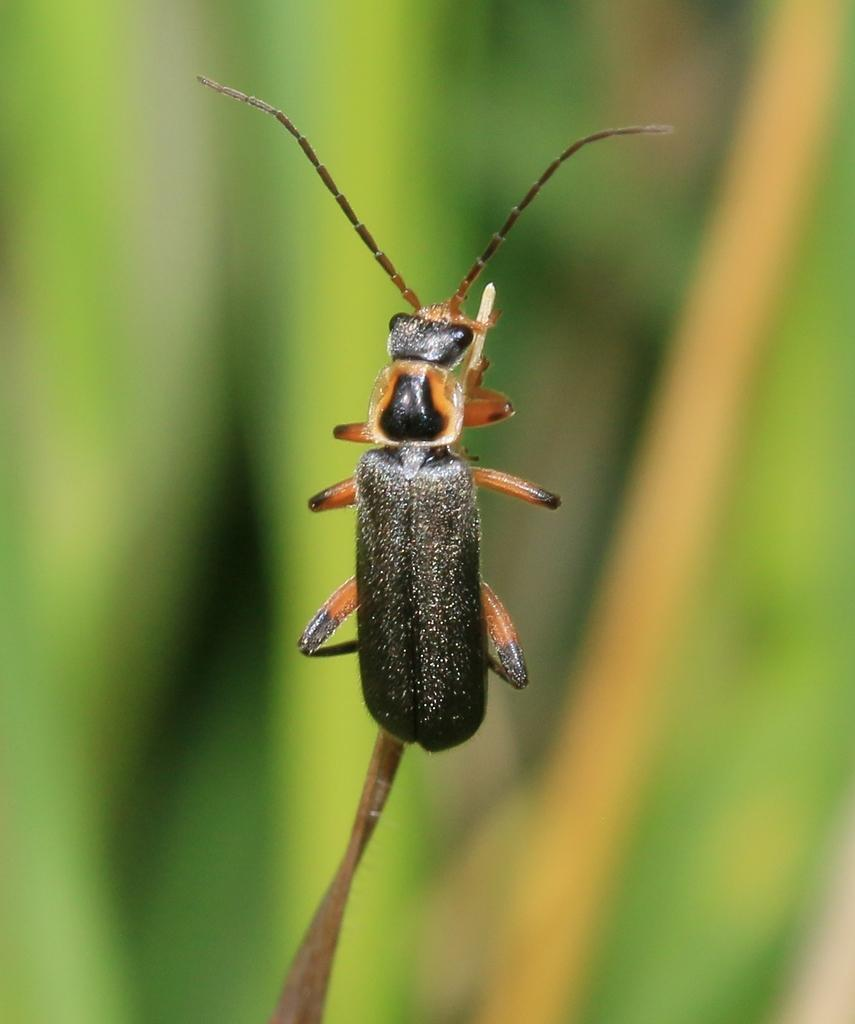What is the main subject in the foreground of the picture? There is an insect in the foreground of the picture. What is the insect holding in the image? The insect is holding a leaf in the image. To which plant does the leaf belong? The leaf belongs to a plant. What can be seen in the background of the image? The background of the image consists of greenery. Is the insect sitting on a throne in the image? No, there is no throne present in the image. The insect is holding a leaf, and the image features greenery in the background. 